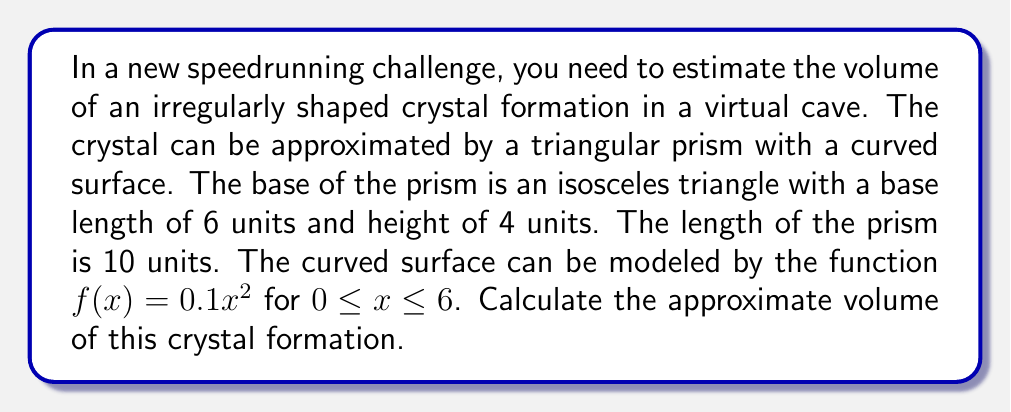Solve this math problem. To estimate the volume of this irregularly shaped object, we'll use the following steps:

1. Calculate the area of the triangular base:
   $$A_{base} = \frac{1}{2} \times base \times height = \frac{1}{2} \times 6 \times 4 = 12\text{ square units}$$

2. If this were a regular triangular prism, its volume would be:
   $$V_{prism} = A_{base} \times length = 12 \times 10 = 120\text{ cubic units}$$

3. However, we need to account for the curved surface. We can do this by calculating the volume between the curved surface and the flat top of the prism, then subtracting it from the regular prism volume.

4. The volume between the curved surface and the flat top can be calculated using integration:
   $$V_{curve} = \int_0^6 \int_0^{10} (0.1x^2) \,dy\,dx$$

5. Solving the integral:
   $$\begin{align}
   V_{curve} &= \int_0^6 10(0.1x^2) \,dx \\
   &= 10 \times 0.1 \times \int_0^6 x^2 \,dx \\
   &= \left. 1 \times \frac{x^3}{3} \right|_0^6 \\
   &= 1 \times \frac{6^3}{3} - 0 \\
   &= 72\text{ cubic units}
   \end{align}$$

6. The final volume is the difference between the regular prism and the curved volume:
   $$V_{final} = V_{prism} - V_{curve} = 120 - 72 = 48\text{ cubic units}$$

This method provides a good approximation of the irregular crystal's volume, which is crucial for speedrunners to quickly estimate object sizes in virtual environments.
Answer: $48\text{ cubic units}$ 